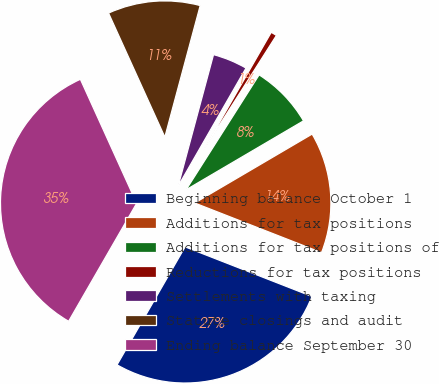Convert chart. <chart><loc_0><loc_0><loc_500><loc_500><pie_chart><fcel>Beginning balance October 1<fcel>Additions for tax positions<fcel>Additions for tax positions of<fcel>Reductions for tax positions<fcel>Settlements with taxing<fcel>Statute closings and audit<fcel>Ending balance September 30<nl><fcel>27.39%<fcel>14.38%<fcel>7.54%<fcel>0.71%<fcel>4.12%<fcel>10.96%<fcel>34.89%<nl></chart> 